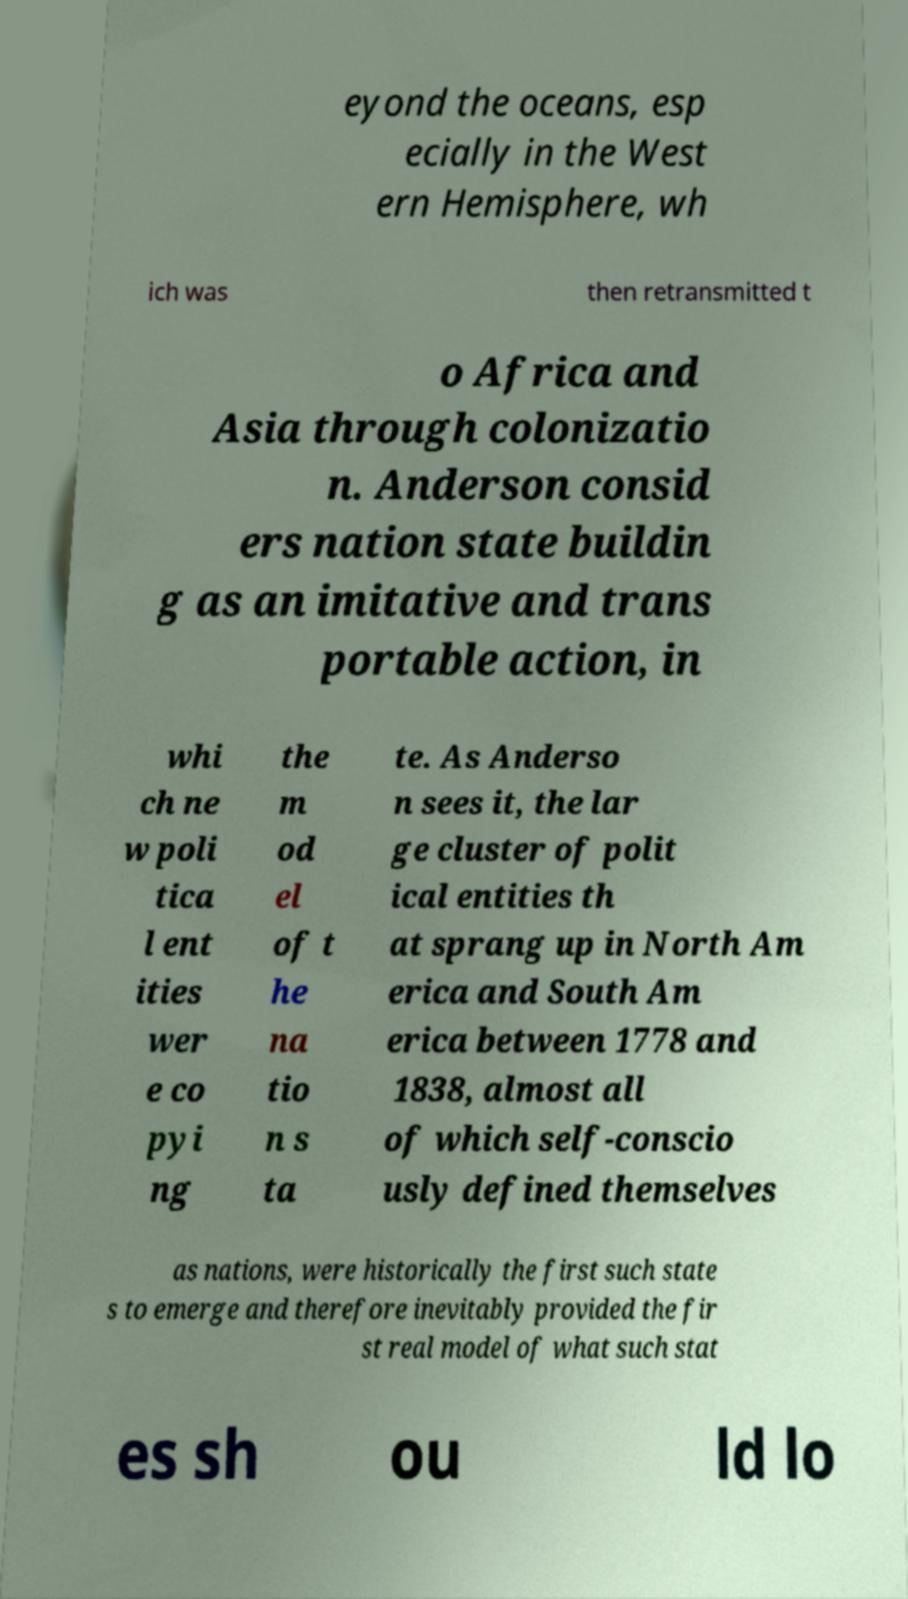What messages or text are displayed in this image? I need them in a readable, typed format. eyond the oceans, esp ecially in the West ern Hemisphere, wh ich was then retransmitted t o Africa and Asia through colonizatio n. Anderson consid ers nation state buildin g as an imitative and trans portable action, in whi ch ne w poli tica l ent ities wer e co pyi ng the m od el of t he na tio n s ta te. As Anderso n sees it, the lar ge cluster of polit ical entities th at sprang up in North Am erica and South Am erica between 1778 and 1838, almost all of which self-conscio usly defined themselves as nations, were historically the first such state s to emerge and therefore inevitably provided the fir st real model of what such stat es sh ou ld lo 